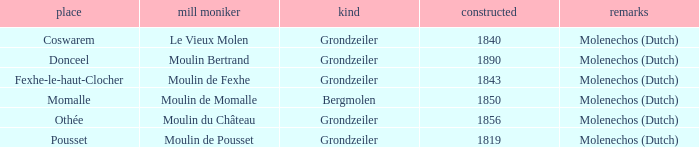What is year Built of the Moulin de Momalle Mill? 1850.0. 